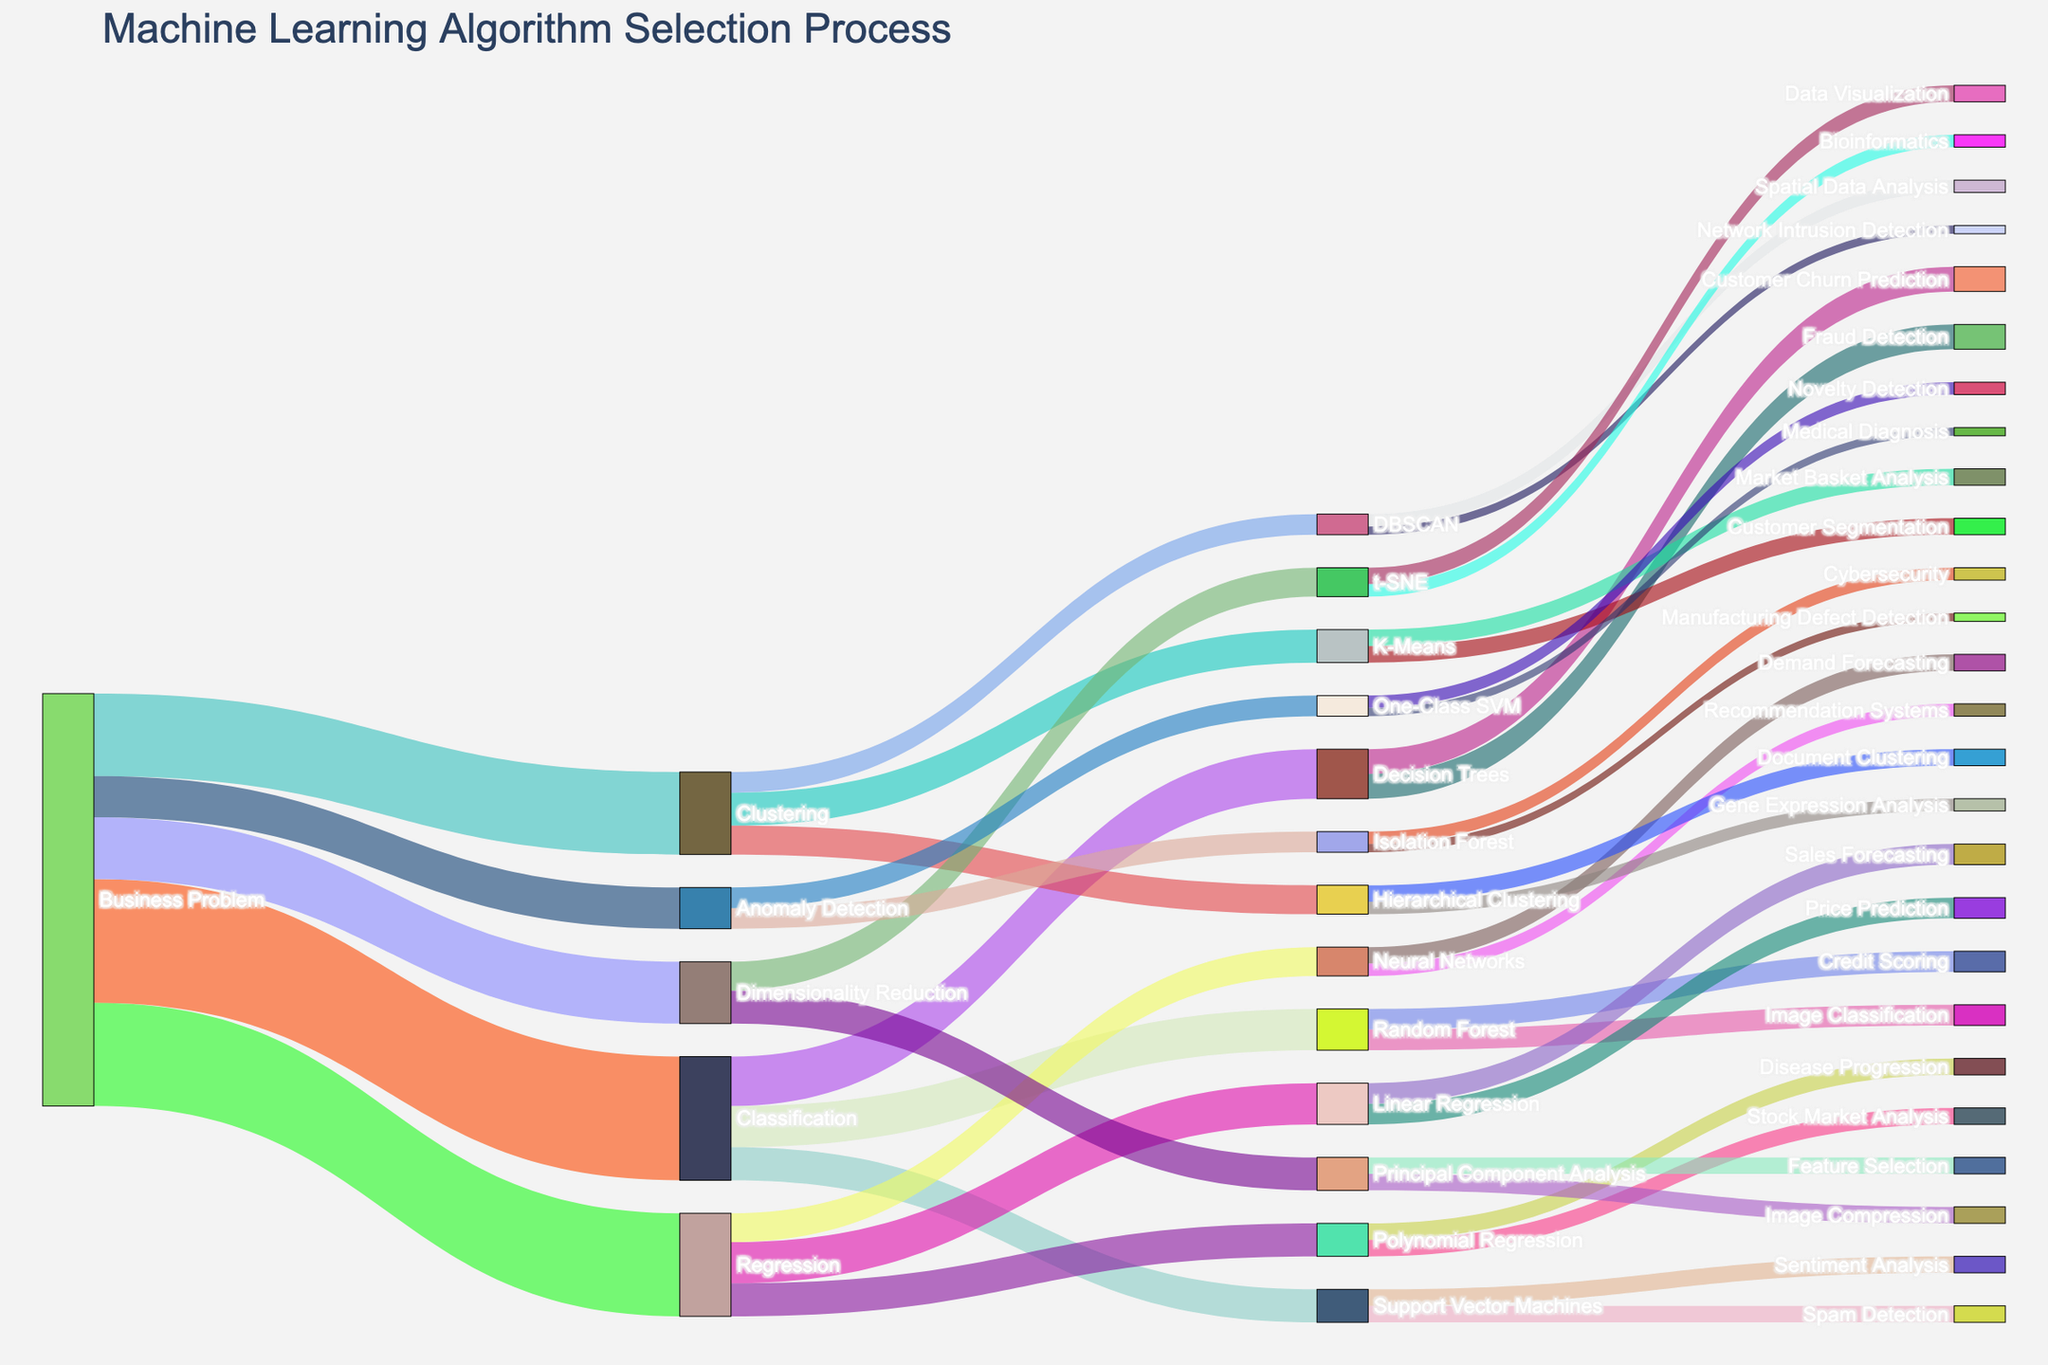what is the title of the figure? The title of a Sankey Diagram is typically displayed prominently, often at the top of the plot, and describes the overall subject of the visualization.
Answer: Machine Learning Algorithm Selection Process how many types of business problems are depicted in the figure? To determine the number of business problems, look at the nodes directly connected to "Business Problem". Each unique connection represents a different type of business problem.
Answer: 5 which business problem has the highest value? Observe the connecting lines (links) from the "Business Problem" node and identify the link with the largest value.
Answer: Classification what machine learning algorithm has the most variety of business applications? Look for the node connected to various business applications through multiple links and count the distinct targets connected to each algorithm node.
Answer: Decision Trees which algorithm is used for Credit Scoring? Search for the link labeled "Credit Scoring" and trace it back to the connected algorithm node.
Answer: Random Forest how many methods are used for Regression problems? Identify all unique nodes connected directly from the "Regression" node. Count these nodes to determine the number of methods used.
Answer: 3 what is the sum of values for Classification problems? Sum the values connected from the "Classification" node to its subsequent nodes. This involves adding 12 (Decision Trees) + 10 (Random Forest) + 8 (Support Vector Machines).
Answer: 30 which business application pairs with Demand Forecasting? Look for the node labeled "Demand Forecasting" and identify the algorithm it connects to.
Answer: Neural Networks compare the value of Clustering and Dimensionality Reduction problems. Which one is greater? Compare the values connected to the "Clustering" node and "Dimensionality Reduction" node. Clustering has a value of 20, while Dimensionality Reduction has a value of 15.
Answer: Clustering how many total links are present in the figure? Count the total number of connections (links) between all nodes in the Sankey Diagram.
Answer: 22 